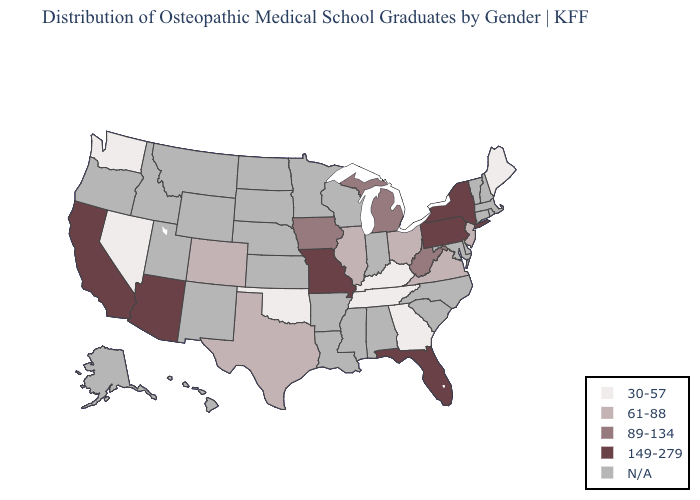What is the value of North Dakota?
Concise answer only. N/A. What is the value of Connecticut?
Give a very brief answer. N/A. Does Maine have the lowest value in the USA?
Concise answer only. Yes. Name the states that have a value in the range 30-57?
Short answer required. Georgia, Kentucky, Maine, Nevada, Oklahoma, Tennessee, Washington. Which states have the highest value in the USA?
Keep it brief. Arizona, California, Florida, Missouri, New York, Pennsylvania. What is the highest value in the USA?
Give a very brief answer. 149-279. Does the first symbol in the legend represent the smallest category?
Short answer required. Yes. Name the states that have a value in the range 61-88?
Be succinct. Colorado, Illinois, New Jersey, Ohio, Texas, Virginia. Which states have the lowest value in the USA?
Give a very brief answer. Georgia, Kentucky, Maine, Nevada, Oklahoma, Tennessee, Washington. Does New Jersey have the lowest value in the Northeast?
Write a very short answer. No. What is the lowest value in the West?
Quick response, please. 30-57. Which states hav the highest value in the Northeast?
Concise answer only. New York, Pennsylvania. Name the states that have a value in the range 61-88?
Short answer required. Colorado, Illinois, New Jersey, Ohio, Texas, Virginia. What is the highest value in the Northeast ?
Short answer required. 149-279. 